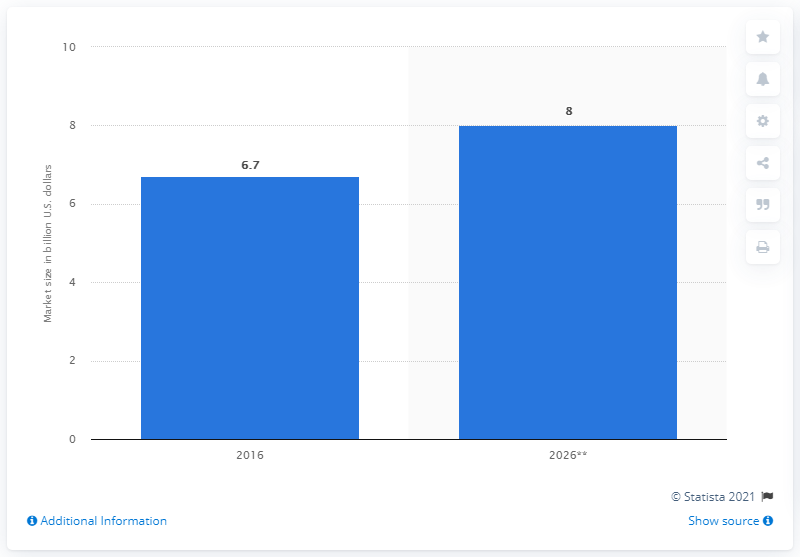Give some essential details in this illustration. The market size for hemophilia A and B in the United States was estimated to be 6.7 billion dollars in 2016. In 2016, the market size for hemophilia A and B was approximately $8. 